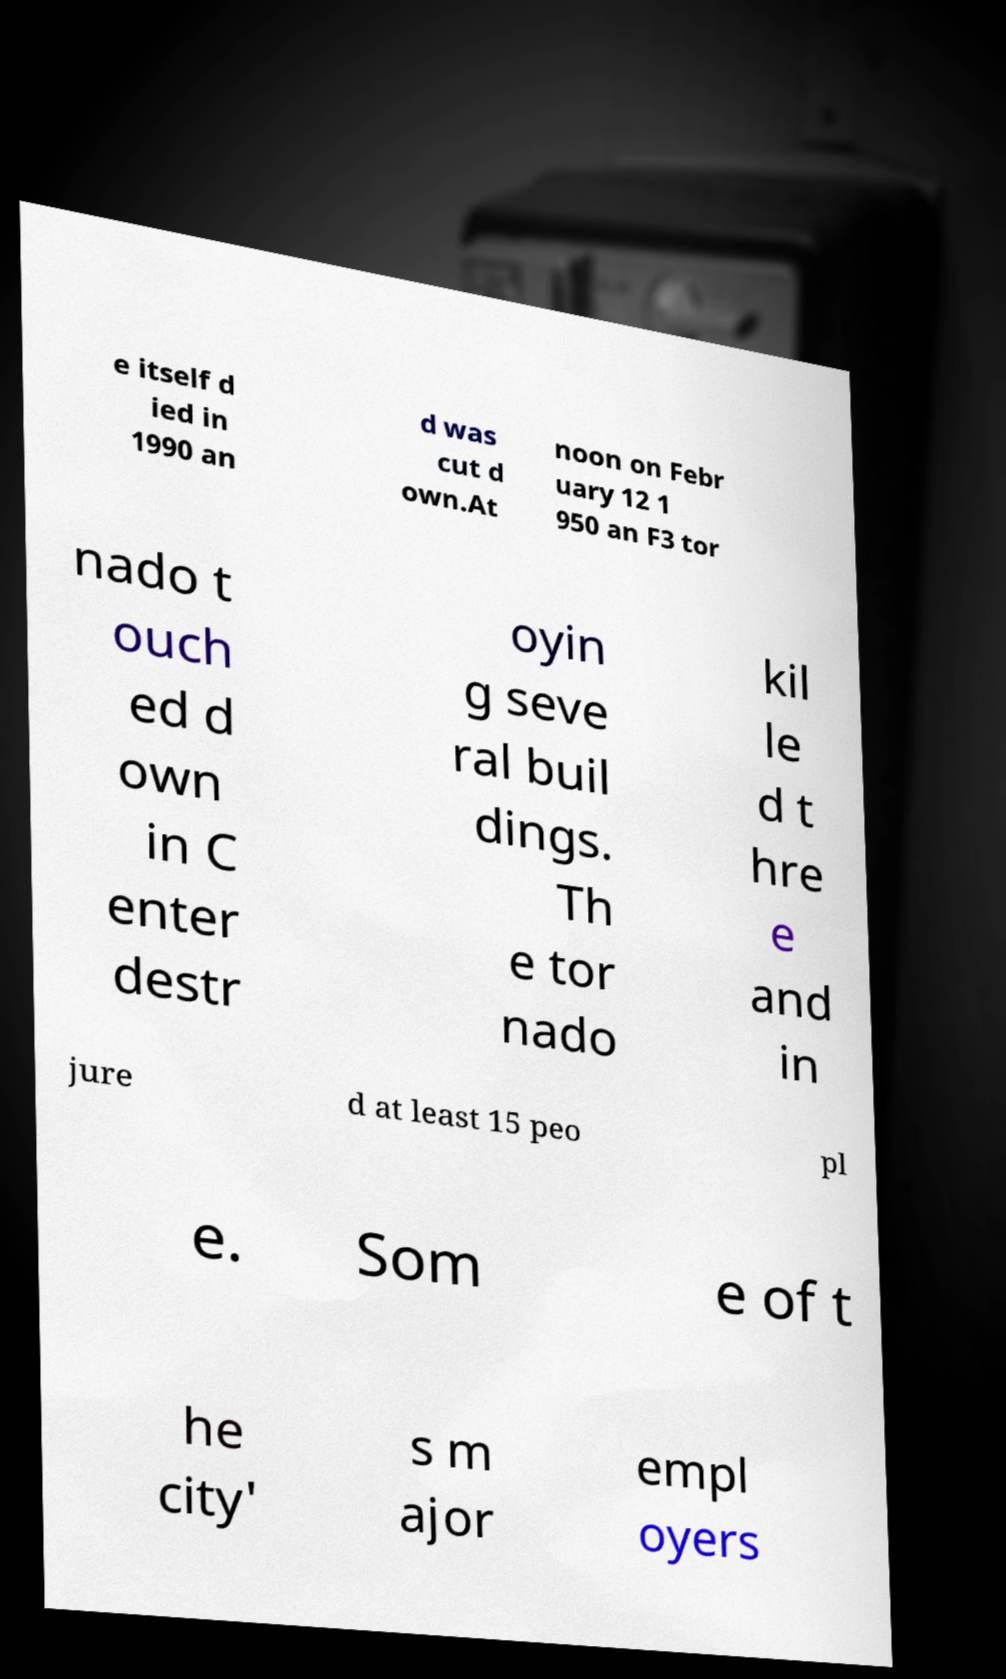For documentation purposes, I need the text within this image transcribed. Could you provide that? e itself d ied in 1990 an d was cut d own.At noon on Febr uary 12 1 950 an F3 tor nado t ouch ed d own in C enter destr oyin g seve ral buil dings. Th e tor nado kil le d t hre e and in jure d at least 15 peo pl e. Som e of t he city' s m ajor empl oyers 